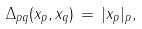<formula> <loc_0><loc_0><loc_500><loc_500>\Delta _ { p q } ( x _ { p } , x _ { q } ) \, = \, | x _ { p } | _ { p } ,</formula> 